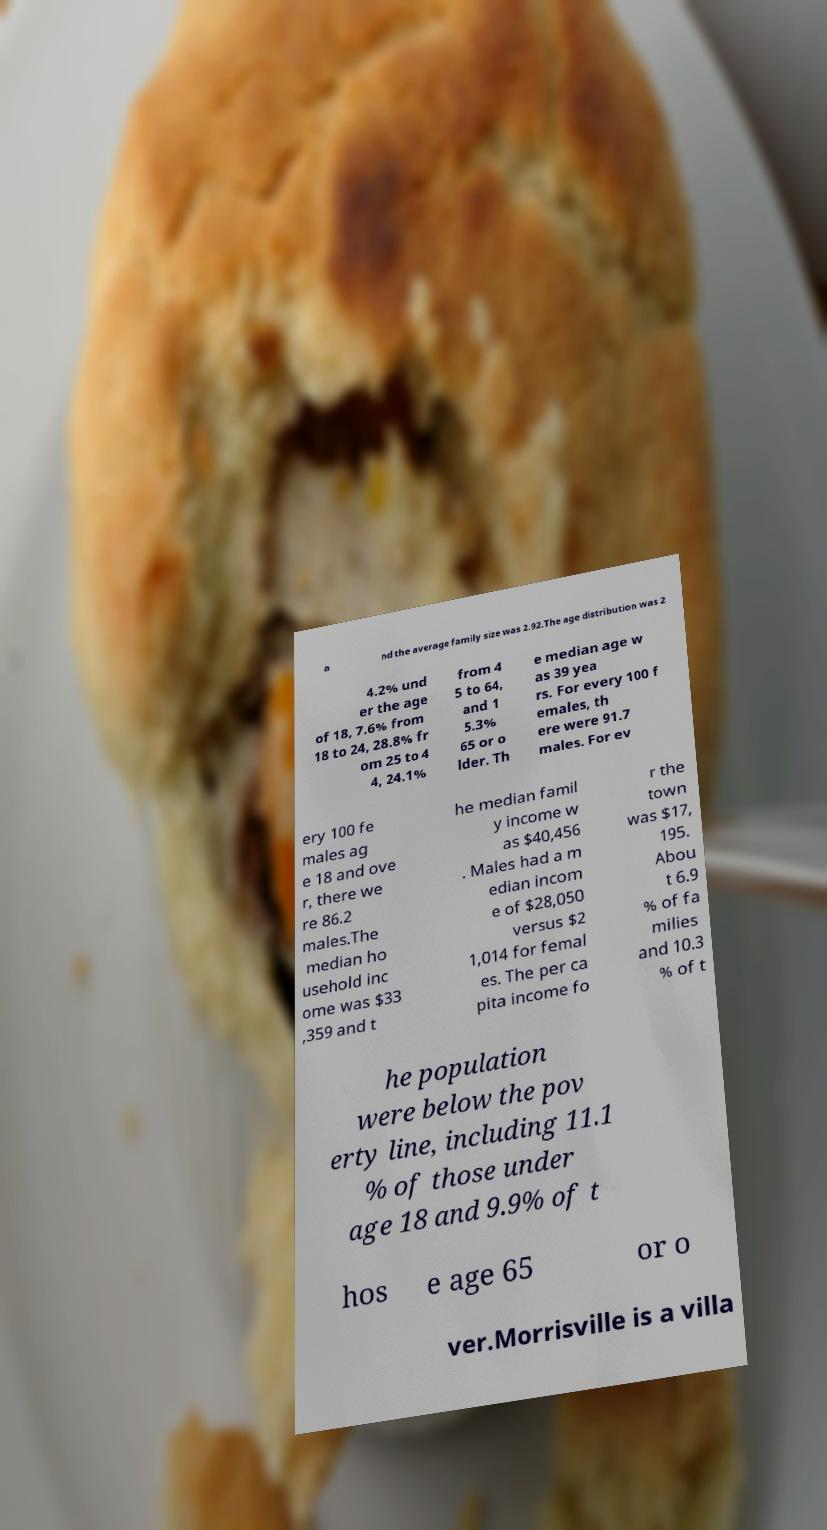Can you accurately transcribe the text from the provided image for me? a nd the average family size was 2.92.The age distribution was 2 4.2% und er the age of 18, 7.6% from 18 to 24, 28.8% fr om 25 to 4 4, 24.1% from 4 5 to 64, and 1 5.3% 65 or o lder. Th e median age w as 39 yea rs. For every 100 f emales, th ere were 91.7 males. For ev ery 100 fe males ag e 18 and ove r, there we re 86.2 males.The median ho usehold inc ome was $33 ,359 and t he median famil y income w as $40,456 . Males had a m edian incom e of $28,050 versus $2 1,014 for femal es. The per ca pita income fo r the town was $17, 195. Abou t 6.9 % of fa milies and 10.3 % of t he population were below the pov erty line, including 11.1 % of those under age 18 and 9.9% of t hos e age 65 or o ver.Morrisville is a villa 